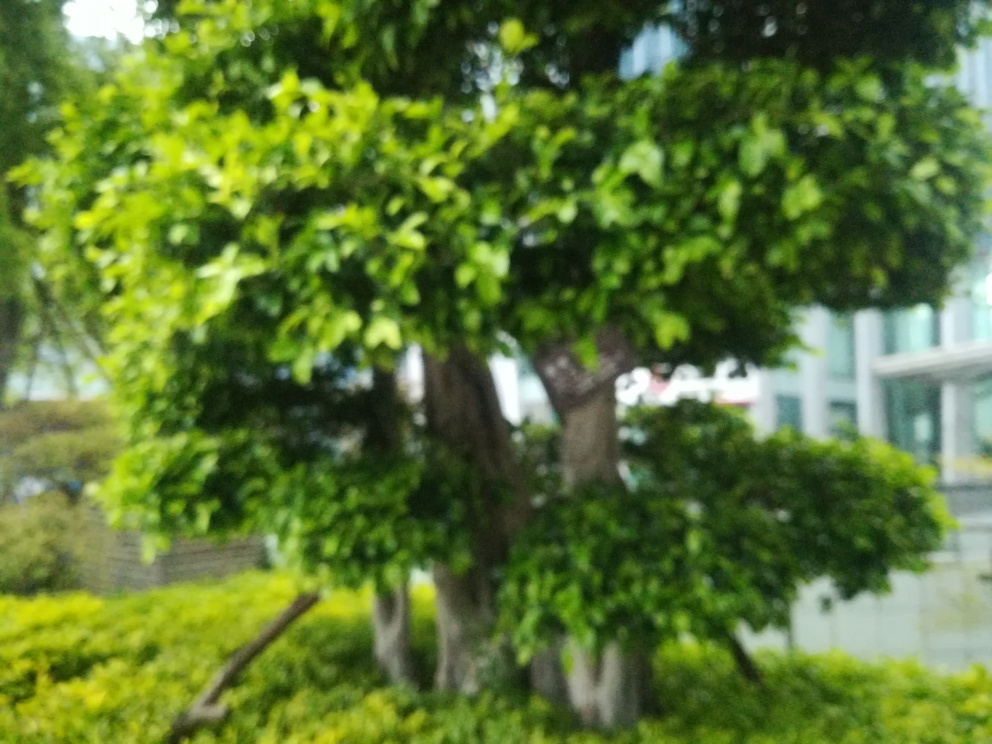Would this image be considered aesthetically pleasing despite its blurriness? Aesthetics can be subjective, but some might find the softness and ambiguity created by the blur to have an artistic or dreamlike quality, which can be appealing in certain contexts. 